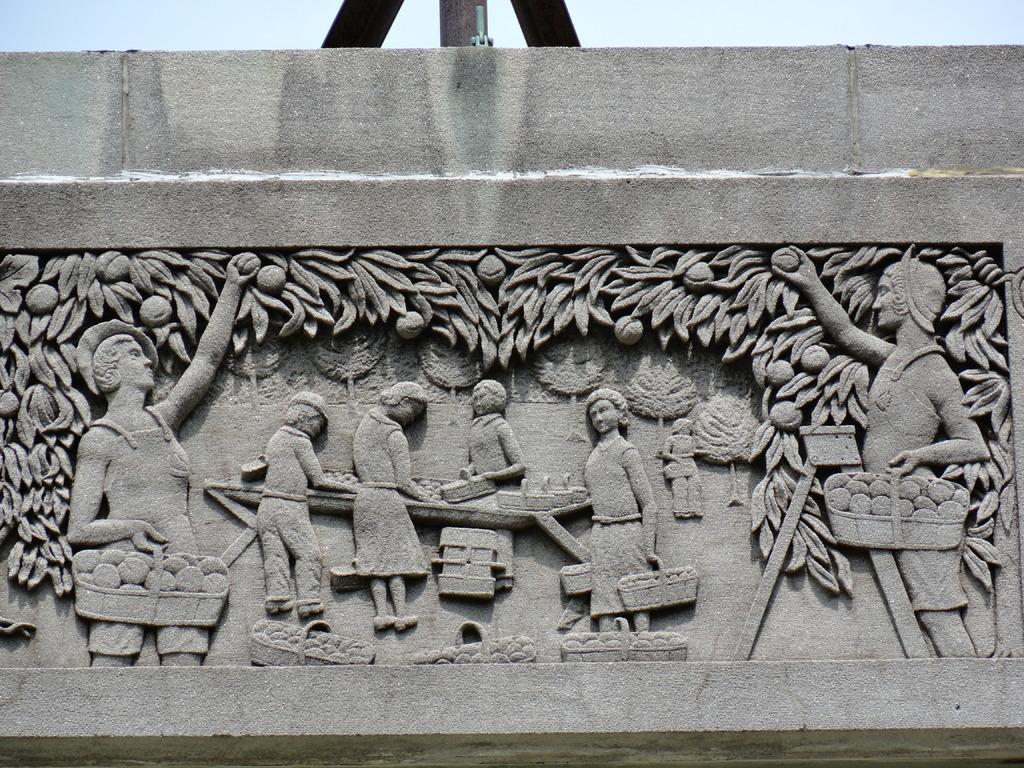Can you describe this image briefly? In this image we can see the sculptures that are engraved on the wall. 